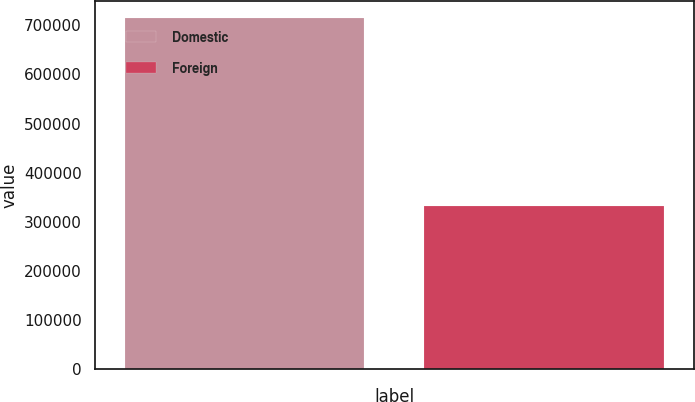<chart> <loc_0><loc_0><loc_500><loc_500><bar_chart><fcel>Domestic<fcel>Foreign<nl><fcel>714723<fcel>331263<nl></chart> 